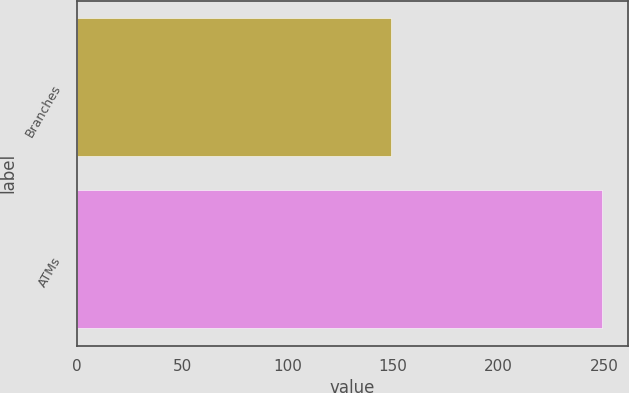Convert chart. <chart><loc_0><loc_0><loc_500><loc_500><bar_chart><fcel>Branches<fcel>ATMs<nl><fcel>149<fcel>249<nl></chart> 